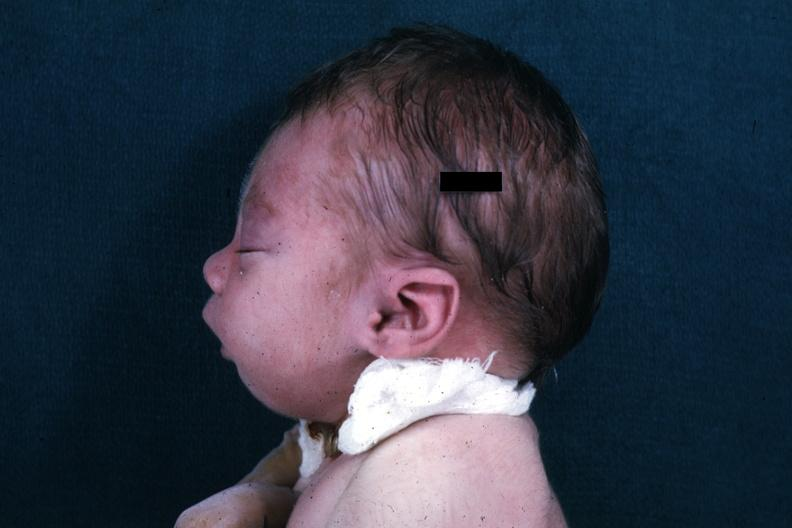what do lateral view of infants head?
Answer the question using a single word or phrase. Showing mandibular lesion 